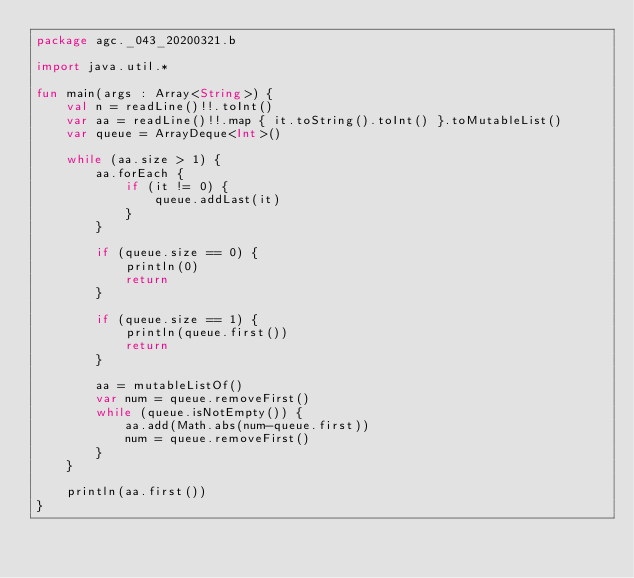Convert code to text. <code><loc_0><loc_0><loc_500><loc_500><_Kotlin_>package agc._043_20200321.b

import java.util.*

fun main(args : Array<String>) {
    val n = readLine()!!.toInt()
    var aa = readLine()!!.map { it.toString().toInt() }.toMutableList()
    var queue = ArrayDeque<Int>()

    while (aa.size > 1) {
        aa.forEach {
            if (it != 0) {
                queue.addLast(it)
            }
        }

        if (queue.size == 0) {
            println(0)
            return
        }

        if (queue.size == 1) {
            println(queue.first())
            return
        }

        aa = mutableListOf()
        var num = queue.removeFirst()
        while (queue.isNotEmpty()) {
            aa.add(Math.abs(num-queue.first))
            num = queue.removeFirst()
        }
    }

    println(aa.first())
}</code> 